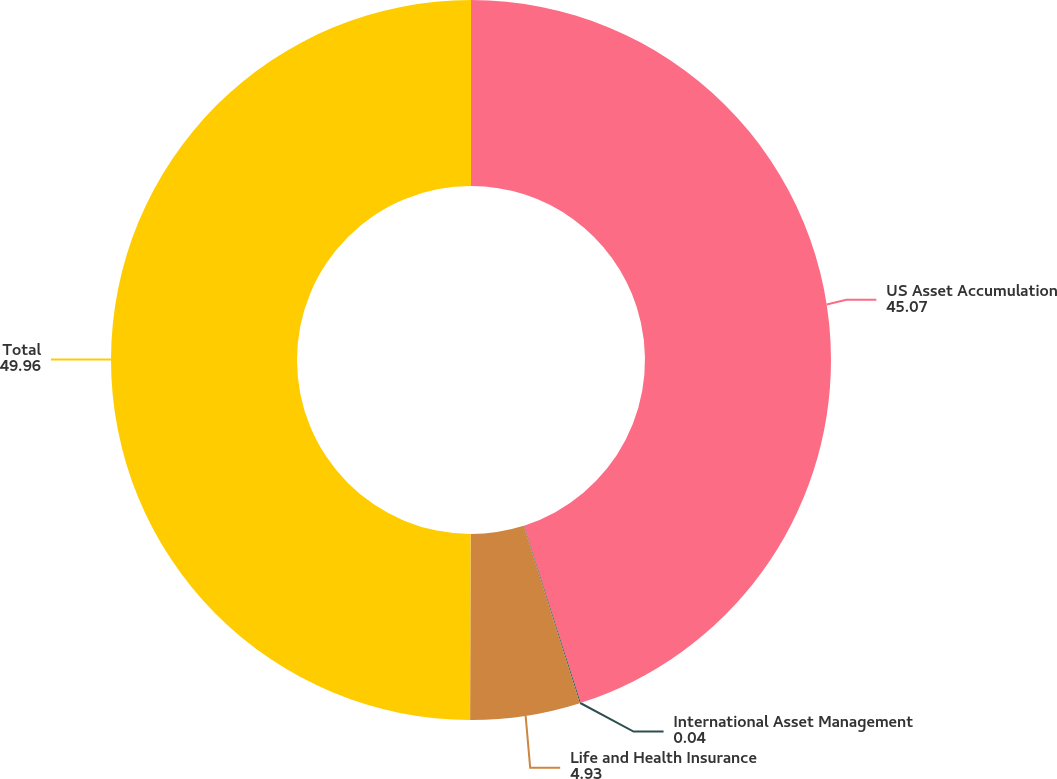Convert chart. <chart><loc_0><loc_0><loc_500><loc_500><pie_chart><fcel>US Asset Accumulation<fcel>International Asset Management<fcel>Life and Health Insurance<fcel>Total<nl><fcel>45.07%<fcel>0.04%<fcel>4.93%<fcel>49.96%<nl></chart> 